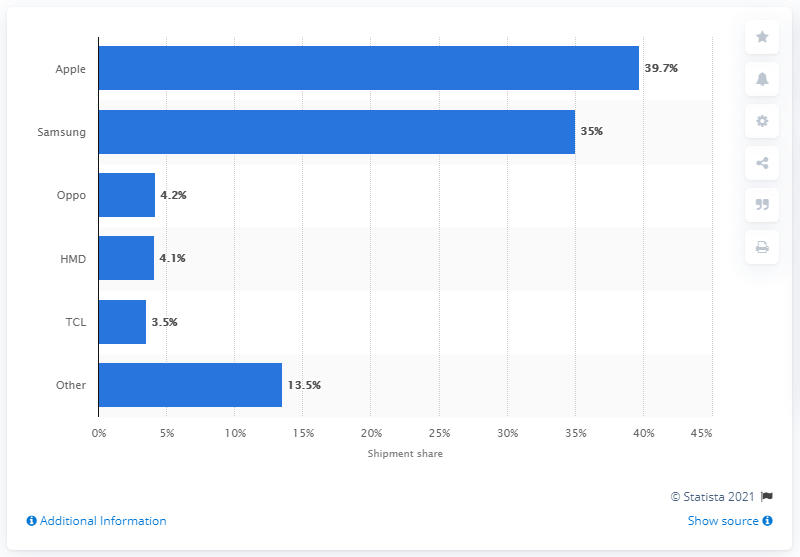Specify some key components in this picture. Apple's market share of smartphones shipped to Australia in the first quarter of 2020 was 39.7%. 